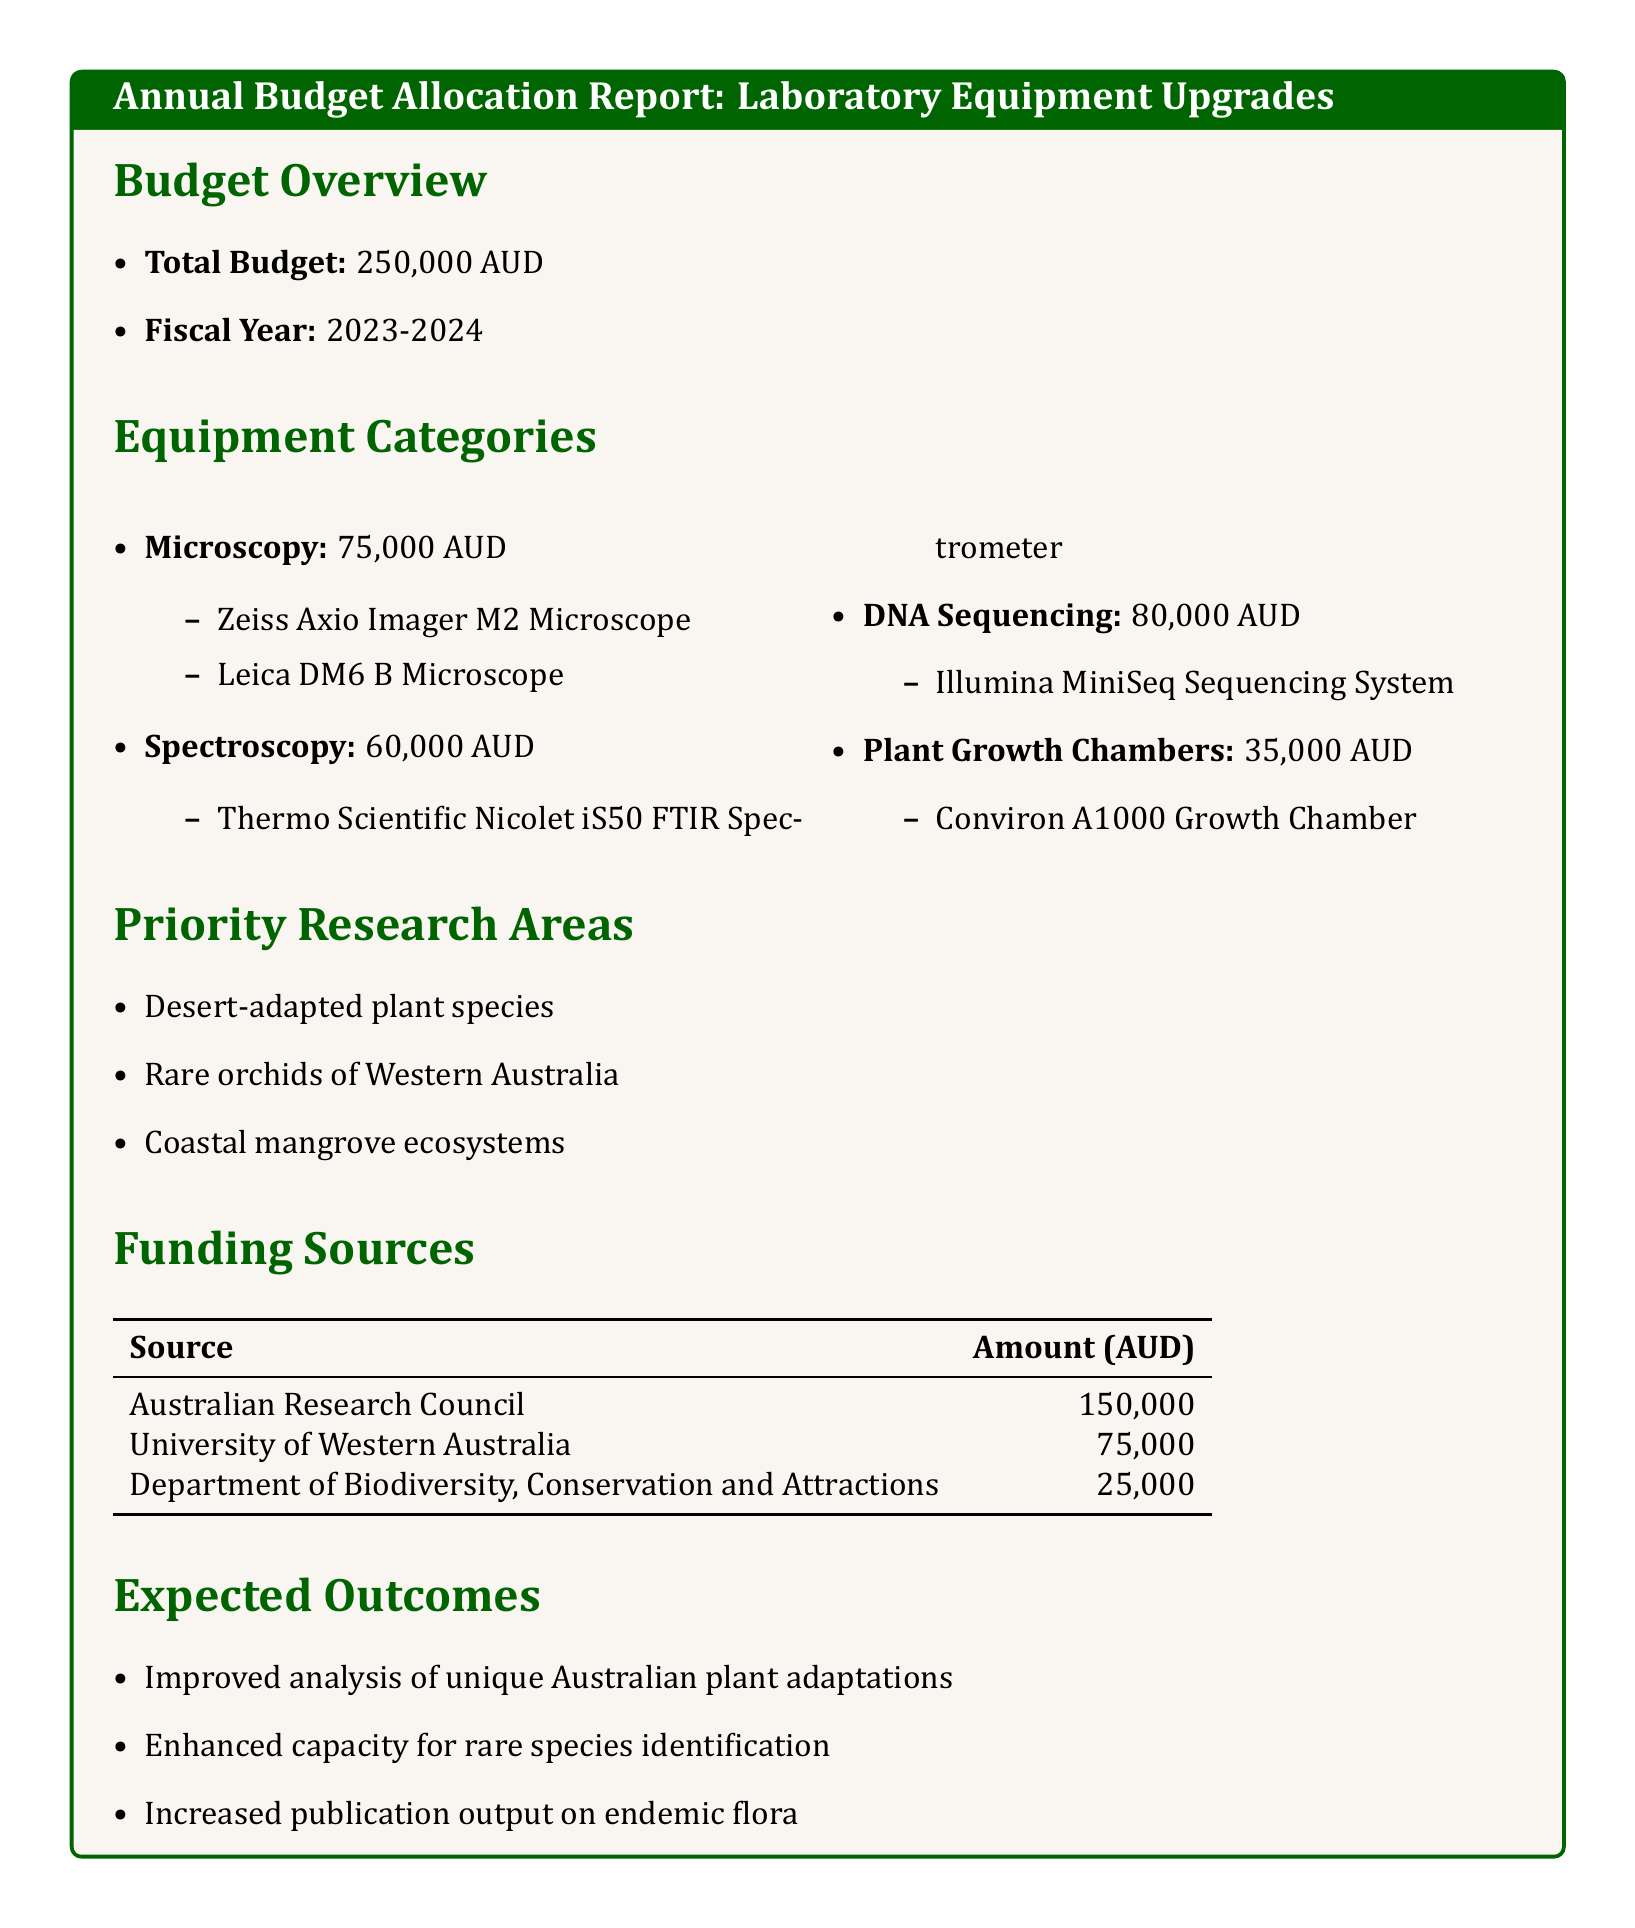what is the total budget? The total budget listed in the document is the overall allocation meant for the upgrades, which is 250000 AUD.
Answer: 250000 AUD how much is allocated for DNA Sequencing? The allocation for DNA Sequencing is explicitly stated in the equipment categories section, which shows it is 80000 AUD.
Answer: 80000 AUD which microscope is included in the Microscopy category? The document lists specific microscopes under the Microscopy category; the two mentioned are Zeiss Axio Imager M2 Microscope and Leica DM6 B Microscope.
Answer: Zeiss Axio Imager M2 Microscope, Leica DM6 B Microscope who is the primary funding source? The primary funding source is identified as the Australian Research Council, which contributes the largest amount as shown in the funding sources table.
Answer: Australian Research Council what is one of the priority research areas? The document enumerates three priority research areas, one of which is Desert-adapted plant species.
Answer: Desert-adapted plant species how much funding comes from the Department of Biodiversity, Conservation and Attractions? The amount contributed by the Department of Biodiversity, Conservation and Attractions is specified in the funding sources section of the document.
Answer: 25000 what is the expected outcome regarding rare species? The expected outcome listed in the document highlights enhancing the capacity for identifying rare species, indicating its significance in the research goals.
Answer: Enhanced capacity for rare species identification how many equipment categories are listed? The document provides information on four distinct categories of equipment allocated for upgrades, summarizing their allocations and items.
Answer: 4 